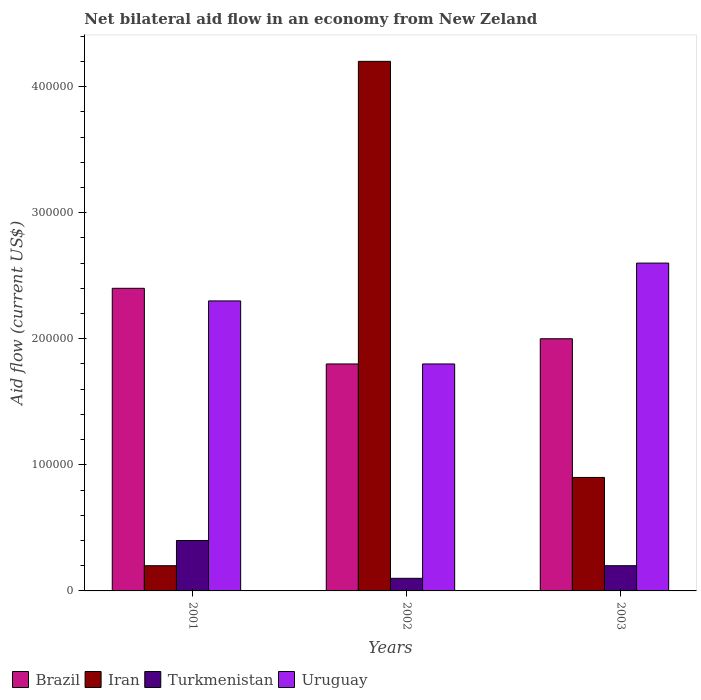What is the label of the 1st group of bars from the left?
Offer a terse response. 2001. Across all years, what is the minimum net bilateral aid flow in Turkmenistan?
Give a very brief answer. 10000. In which year was the net bilateral aid flow in Uruguay maximum?
Ensure brevity in your answer.  2003. What is the total net bilateral aid flow in Iran in the graph?
Provide a short and direct response. 5.30e+05. What is the difference between the net bilateral aid flow in Turkmenistan in 2003 and the net bilateral aid flow in Brazil in 2001?
Make the answer very short. -2.20e+05. What is the average net bilateral aid flow in Uruguay per year?
Give a very brief answer. 2.23e+05. In the year 2001, what is the difference between the net bilateral aid flow in Iran and net bilateral aid flow in Uruguay?
Your answer should be compact. -2.10e+05. In how many years, is the net bilateral aid flow in Iran greater than 80000 US$?
Provide a succinct answer. 2. What is the ratio of the net bilateral aid flow in Uruguay in 2001 to that in 2003?
Your answer should be very brief. 0.88. Is the net bilateral aid flow in Iran in 2001 less than that in 2003?
Your answer should be compact. Yes. Is the difference between the net bilateral aid flow in Iran in 2001 and 2003 greater than the difference between the net bilateral aid flow in Uruguay in 2001 and 2003?
Offer a terse response. No. What is the difference between the highest and the second highest net bilateral aid flow in Turkmenistan?
Provide a succinct answer. 2.00e+04. Is the sum of the net bilateral aid flow in Brazil in 2002 and 2003 greater than the maximum net bilateral aid flow in Uruguay across all years?
Your response must be concise. Yes. Is it the case that in every year, the sum of the net bilateral aid flow in Iran and net bilateral aid flow in Uruguay is greater than the sum of net bilateral aid flow in Turkmenistan and net bilateral aid flow in Brazil?
Your response must be concise. No. What does the 3rd bar from the left in 2001 represents?
Provide a succinct answer. Turkmenistan. What does the 1st bar from the right in 2002 represents?
Your response must be concise. Uruguay. How many bars are there?
Provide a short and direct response. 12. Are the values on the major ticks of Y-axis written in scientific E-notation?
Provide a short and direct response. No. Does the graph contain grids?
Give a very brief answer. No. What is the title of the graph?
Your response must be concise. Net bilateral aid flow in an economy from New Zeland. What is the label or title of the X-axis?
Offer a terse response. Years. What is the label or title of the Y-axis?
Keep it short and to the point. Aid flow (current US$). What is the Aid flow (current US$) of Iran in 2001?
Your answer should be compact. 2.00e+04. What is the Aid flow (current US$) in Turkmenistan in 2001?
Make the answer very short. 4.00e+04. What is the Aid flow (current US$) in Uruguay in 2001?
Provide a succinct answer. 2.30e+05. What is the Aid flow (current US$) in Brazil in 2002?
Offer a very short reply. 1.80e+05. What is the Aid flow (current US$) of Uruguay in 2002?
Keep it short and to the point. 1.80e+05. What is the Aid flow (current US$) in Brazil in 2003?
Offer a very short reply. 2.00e+05. What is the Aid flow (current US$) of Iran in 2003?
Ensure brevity in your answer.  9.00e+04. What is the Aid flow (current US$) of Turkmenistan in 2003?
Your response must be concise. 2.00e+04. What is the Aid flow (current US$) of Uruguay in 2003?
Your answer should be compact. 2.60e+05. Across all years, what is the maximum Aid flow (current US$) in Brazil?
Make the answer very short. 2.40e+05. Across all years, what is the maximum Aid flow (current US$) of Uruguay?
Ensure brevity in your answer.  2.60e+05. Across all years, what is the minimum Aid flow (current US$) in Brazil?
Provide a succinct answer. 1.80e+05. Across all years, what is the minimum Aid flow (current US$) in Uruguay?
Your response must be concise. 1.80e+05. What is the total Aid flow (current US$) of Brazil in the graph?
Make the answer very short. 6.20e+05. What is the total Aid flow (current US$) of Iran in the graph?
Provide a short and direct response. 5.30e+05. What is the total Aid flow (current US$) of Uruguay in the graph?
Offer a terse response. 6.70e+05. What is the difference between the Aid flow (current US$) in Brazil in 2001 and that in 2002?
Provide a short and direct response. 6.00e+04. What is the difference between the Aid flow (current US$) in Iran in 2001 and that in 2002?
Your response must be concise. -4.00e+05. What is the difference between the Aid flow (current US$) in Brazil in 2001 and that in 2003?
Provide a succinct answer. 4.00e+04. What is the difference between the Aid flow (current US$) in Iran in 2001 and that in 2003?
Your answer should be very brief. -7.00e+04. What is the difference between the Aid flow (current US$) in Turkmenistan in 2001 and that in 2003?
Offer a terse response. 2.00e+04. What is the difference between the Aid flow (current US$) in Iran in 2002 and that in 2003?
Provide a succinct answer. 3.30e+05. What is the difference between the Aid flow (current US$) in Turkmenistan in 2001 and the Aid flow (current US$) in Uruguay in 2002?
Your answer should be very brief. -1.40e+05. What is the difference between the Aid flow (current US$) of Brazil in 2001 and the Aid flow (current US$) of Iran in 2003?
Ensure brevity in your answer.  1.50e+05. What is the difference between the Aid flow (current US$) in Brazil in 2001 and the Aid flow (current US$) in Turkmenistan in 2003?
Give a very brief answer. 2.20e+05. What is the difference between the Aid flow (current US$) of Iran in 2001 and the Aid flow (current US$) of Turkmenistan in 2003?
Give a very brief answer. 0. What is the difference between the Aid flow (current US$) in Iran in 2001 and the Aid flow (current US$) in Uruguay in 2003?
Your answer should be very brief. -2.40e+05. What is the difference between the Aid flow (current US$) of Turkmenistan in 2001 and the Aid flow (current US$) of Uruguay in 2003?
Your answer should be compact. -2.20e+05. What is the difference between the Aid flow (current US$) in Brazil in 2002 and the Aid flow (current US$) in Iran in 2003?
Your answer should be very brief. 9.00e+04. What is the difference between the Aid flow (current US$) in Brazil in 2002 and the Aid flow (current US$) in Turkmenistan in 2003?
Make the answer very short. 1.60e+05. What is the difference between the Aid flow (current US$) of Iran in 2002 and the Aid flow (current US$) of Turkmenistan in 2003?
Offer a very short reply. 4.00e+05. What is the difference between the Aid flow (current US$) in Turkmenistan in 2002 and the Aid flow (current US$) in Uruguay in 2003?
Provide a succinct answer. -2.50e+05. What is the average Aid flow (current US$) of Brazil per year?
Provide a short and direct response. 2.07e+05. What is the average Aid flow (current US$) in Iran per year?
Provide a succinct answer. 1.77e+05. What is the average Aid flow (current US$) of Turkmenistan per year?
Provide a succinct answer. 2.33e+04. What is the average Aid flow (current US$) of Uruguay per year?
Your response must be concise. 2.23e+05. In the year 2001, what is the difference between the Aid flow (current US$) in Brazil and Aid flow (current US$) in Iran?
Provide a succinct answer. 2.20e+05. In the year 2001, what is the difference between the Aid flow (current US$) of Brazil and Aid flow (current US$) of Turkmenistan?
Provide a short and direct response. 2.00e+05. In the year 2001, what is the difference between the Aid flow (current US$) in Brazil and Aid flow (current US$) in Uruguay?
Your response must be concise. 10000. In the year 2001, what is the difference between the Aid flow (current US$) in Iran and Aid flow (current US$) in Turkmenistan?
Give a very brief answer. -2.00e+04. In the year 2001, what is the difference between the Aid flow (current US$) in Iran and Aid flow (current US$) in Uruguay?
Provide a short and direct response. -2.10e+05. In the year 2001, what is the difference between the Aid flow (current US$) of Turkmenistan and Aid flow (current US$) of Uruguay?
Offer a very short reply. -1.90e+05. In the year 2002, what is the difference between the Aid flow (current US$) in Brazil and Aid flow (current US$) in Iran?
Make the answer very short. -2.40e+05. In the year 2002, what is the difference between the Aid flow (current US$) in Brazil and Aid flow (current US$) in Turkmenistan?
Your answer should be very brief. 1.70e+05. In the year 2002, what is the difference between the Aid flow (current US$) in Brazil and Aid flow (current US$) in Uruguay?
Make the answer very short. 0. In the year 2002, what is the difference between the Aid flow (current US$) of Iran and Aid flow (current US$) of Turkmenistan?
Provide a succinct answer. 4.10e+05. In the year 2002, what is the difference between the Aid flow (current US$) in Turkmenistan and Aid flow (current US$) in Uruguay?
Give a very brief answer. -1.70e+05. In the year 2003, what is the difference between the Aid flow (current US$) in Brazil and Aid flow (current US$) in Iran?
Keep it short and to the point. 1.10e+05. In the year 2003, what is the difference between the Aid flow (current US$) of Brazil and Aid flow (current US$) of Uruguay?
Give a very brief answer. -6.00e+04. In the year 2003, what is the difference between the Aid flow (current US$) in Iran and Aid flow (current US$) in Turkmenistan?
Provide a succinct answer. 7.00e+04. In the year 2003, what is the difference between the Aid flow (current US$) in Turkmenistan and Aid flow (current US$) in Uruguay?
Keep it short and to the point. -2.40e+05. What is the ratio of the Aid flow (current US$) of Iran in 2001 to that in 2002?
Give a very brief answer. 0.05. What is the ratio of the Aid flow (current US$) in Uruguay in 2001 to that in 2002?
Your answer should be very brief. 1.28. What is the ratio of the Aid flow (current US$) of Iran in 2001 to that in 2003?
Provide a short and direct response. 0.22. What is the ratio of the Aid flow (current US$) in Turkmenistan in 2001 to that in 2003?
Your answer should be compact. 2. What is the ratio of the Aid flow (current US$) of Uruguay in 2001 to that in 2003?
Provide a short and direct response. 0.88. What is the ratio of the Aid flow (current US$) in Brazil in 2002 to that in 2003?
Provide a succinct answer. 0.9. What is the ratio of the Aid flow (current US$) of Iran in 2002 to that in 2003?
Provide a succinct answer. 4.67. What is the ratio of the Aid flow (current US$) of Uruguay in 2002 to that in 2003?
Your answer should be very brief. 0.69. What is the difference between the highest and the lowest Aid flow (current US$) in Brazil?
Your answer should be compact. 6.00e+04. What is the difference between the highest and the lowest Aid flow (current US$) of Iran?
Ensure brevity in your answer.  4.00e+05. 